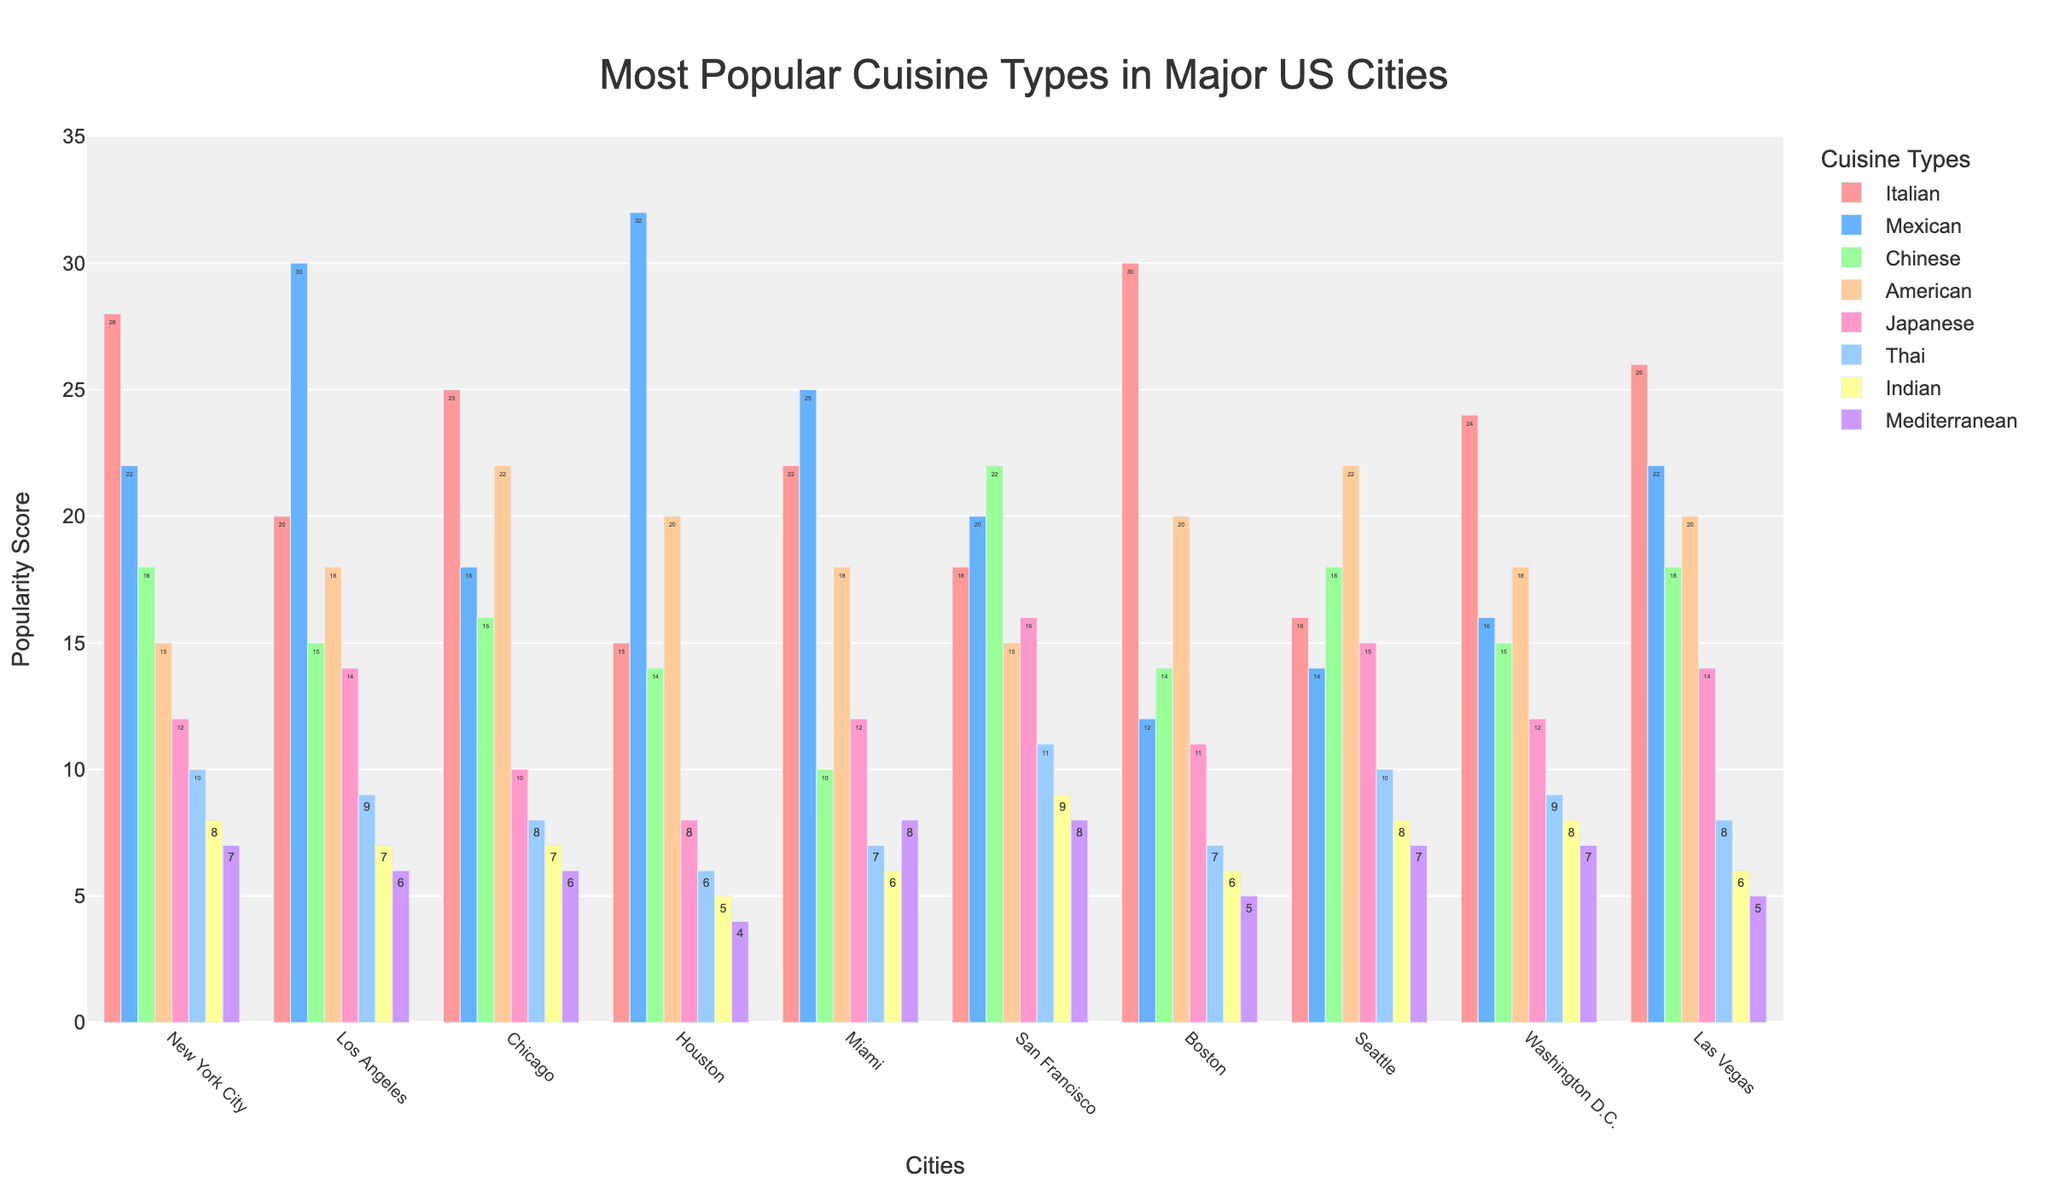What's the most popular cuisine type in Houston? By visually scanning the height of the bars for Houston, the tallest bar corresponds to the Mexican cuisine.
Answer: Mexican Which city has the least popularity for Indian cuisine? By comparing the heights of the bars representing Indian cuisine across all cities, Houston has the shortest bar.
Answer: Houston In which city is the popularity of American cuisine equal to the popularity of Mexican cuisine in Chicago? The bar height for American cuisine in Chicago is 22. By looking at the bars for American cuisine, Seattle also has a height of 22 for American cuisine.
Answer: Seattle How much more popular is Japanese cuisine in San Francisco compared to Boston? The popularity of Japanese cuisine in San Francisco is 16 and in Boston is 11. The difference is 16 - 11.
Answer: 5 What is the average popularity of Italian cuisine across all cities? Add the popularity values of Italian cuisine for all cities (28 + 20 + 25 + 15 + 22 + 18 + 30 + 16 + 24 + 26), which sums up to 224. Then divide by the number of cities, 224 / 10.
Answer: 22.4 Which city has the closest popularity scores for Thai and Mediterranean cuisines? By comparing the heights of the bars representing Thai and Mediterranean cuisines in all cities, New York City has the very close scores of 10 for Thai and 7 for Mediterranean.
Answer: New York City Is American or Italian cuisine more popular in Boston? By comparing the heights of the American cuisine bar (20) and Italian cuisine bar (30) in Boston, Italian cuisine is more popular.
Answer: Italian On average, how much more popular is Mexican cuisine compared to Indian cuisine across all cities? Sum the popularity values for Mexican cuisine (22 + 30 + 18 + 32 + 25 + 20 + 12 + 14 + 16 + 22 = 211) and for Indian cuisine (8 + 7 + 7 + 5 + 6 + 9 + 6 + 8 + 8 + 6 = 70). The average difference is (211 - 70) / 10.
Answer: 14.1 Which city has the highest average popularity across all cuisine types? Calculate the average popularity for each city by summing the values for each city and then dividing by the number of cuisine types. The city with the highest average points out as New York City (avg = 120/8 = 15).
Answer: New York City 